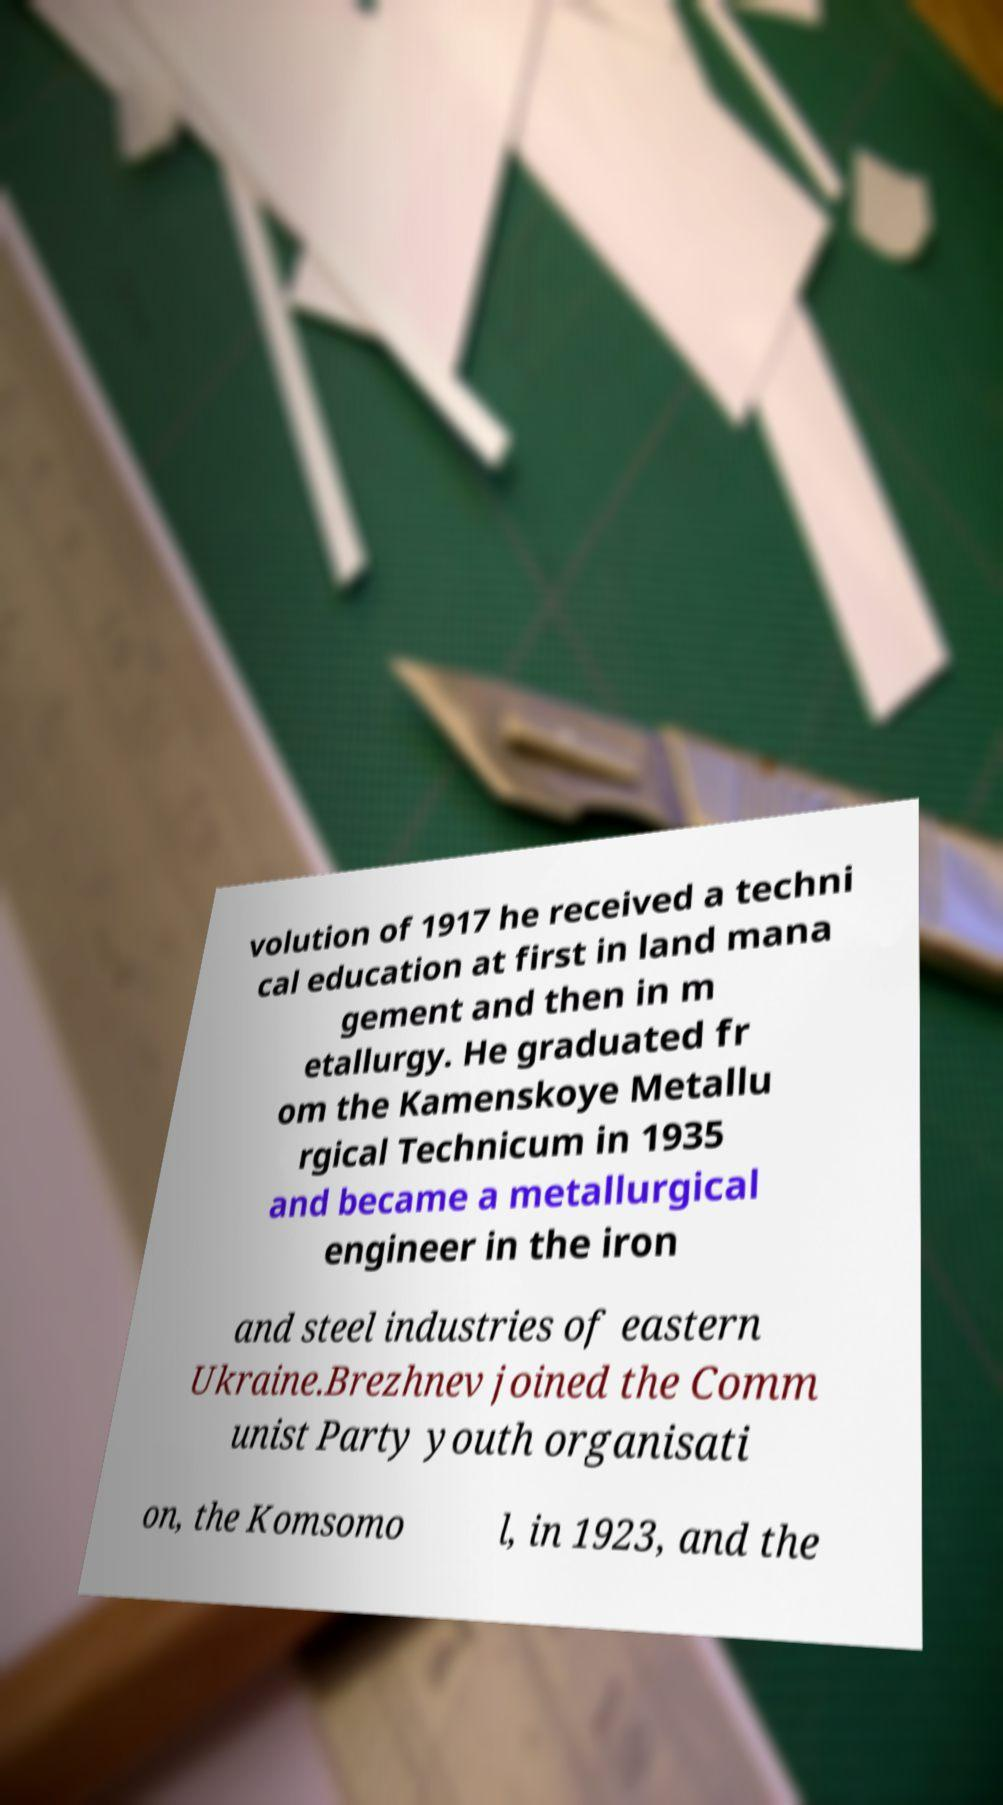Could you extract and type out the text from this image? volution of 1917 he received a techni cal education at first in land mana gement and then in m etallurgy. He graduated fr om the Kamenskoye Metallu rgical Technicum in 1935 and became a metallurgical engineer in the iron and steel industries of eastern Ukraine.Brezhnev joined the Comm unist Party youth organisati on, the Komsomo l, in 1923, and the 